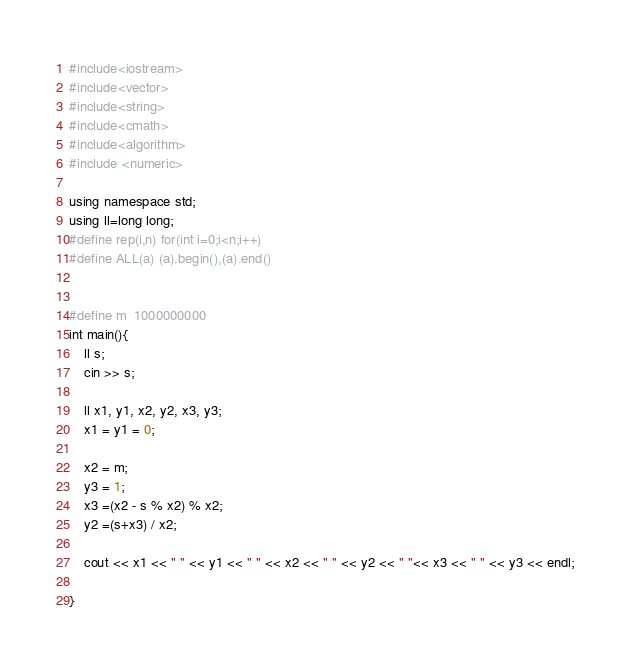Convert code to text. <code><loc_0><loc_0><loc_500><loc_500><_C++_>#include<iostream>
#include<vector>
#include<string>
#include<cmath>
#include<algorithm>
#include <numeric>
 
using namespace std;
using ll=long long;
#define rep(i,n) for(int i=0;i<n;i++)
#define ALL(a) (a).begin(),(a).end()


#define m  1000000000
int main(){
    ll s;
    cin >> s; 
    
    ll x1, y1, x2, y2, x3, y3;
    x1 = y1 = 0;

    x2 = m;
    y3 = 1;
    x3 =(x2 - s % x2) % x2;
	y2 =(s+x3) / x2;

    cout << x1 << " " << y1 << " " << x2 << " " << y2 << " "<< x3 << " " << y3 << endl;
    
}</code> 